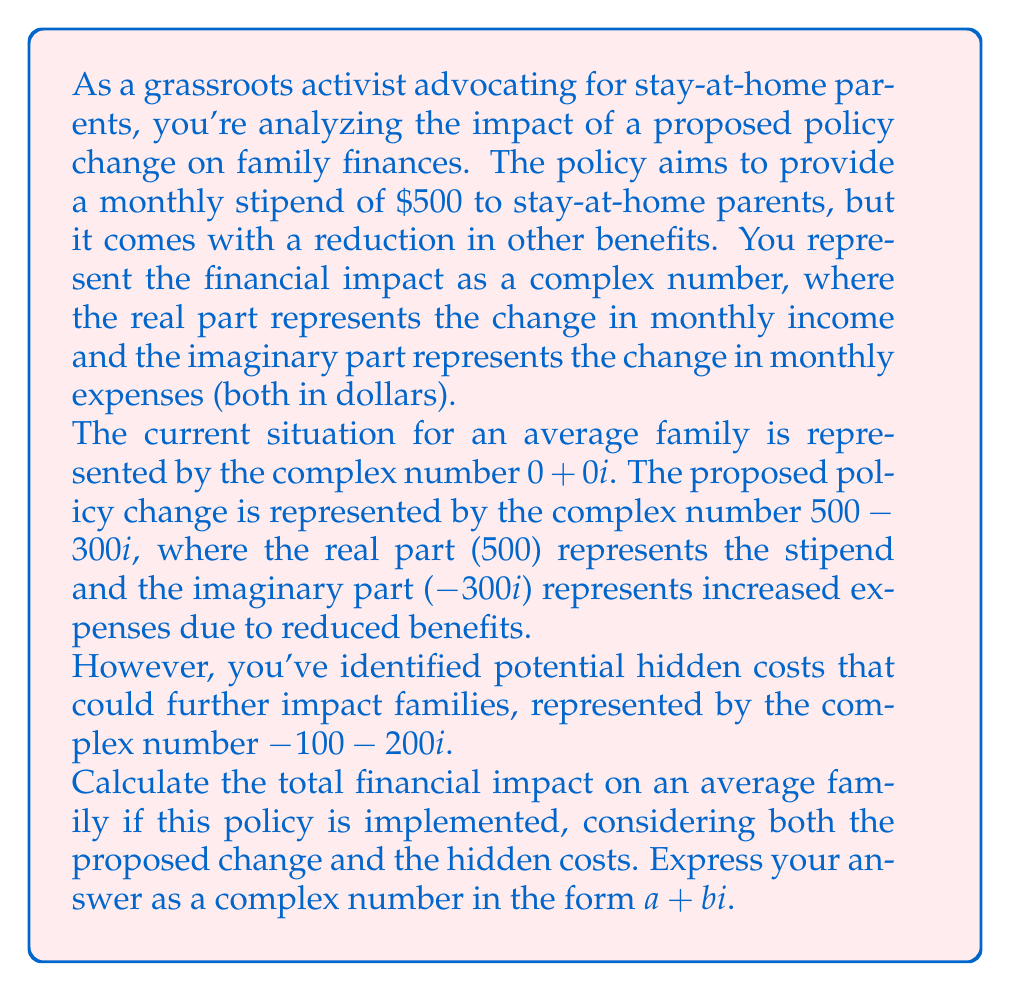Solve this math problem. To solve this problem, we need to add the complex numbers representing the current situation, the proposed policy change, and the hidden costs. Let's break it down step by step:

1) Current situation: $0 + 0i$
2) Proposed policy change: $500 - 300i$
3) Hidden costs: $-100 - 200i$

To add complex numbers, we add the real parts and the imaginary parts separately:

$$(0 + 0i) + (500 - 300i) + (-100 - 200i)$$

Let's add the real parts:
$$0 + 500 + (-100) = 400$$

Now, let's add the imaginary parts:
$$0i + (-300i) + (-200i) = -500i$$

Combining the real and imaginary parts, we get:

$$400 - 500i$$

This result means that the average family would experience:
- An increase in monthly income of $400 (represented by the real part)
- An increase in monthly expenses of $500 (represented by the coefficient of the imaginary part)

The negative sign before the imaginary part indicates that expenses are increasing, as we defined the imaginary part to represent changes in expenses.
Answer: $400 - 500i$ 